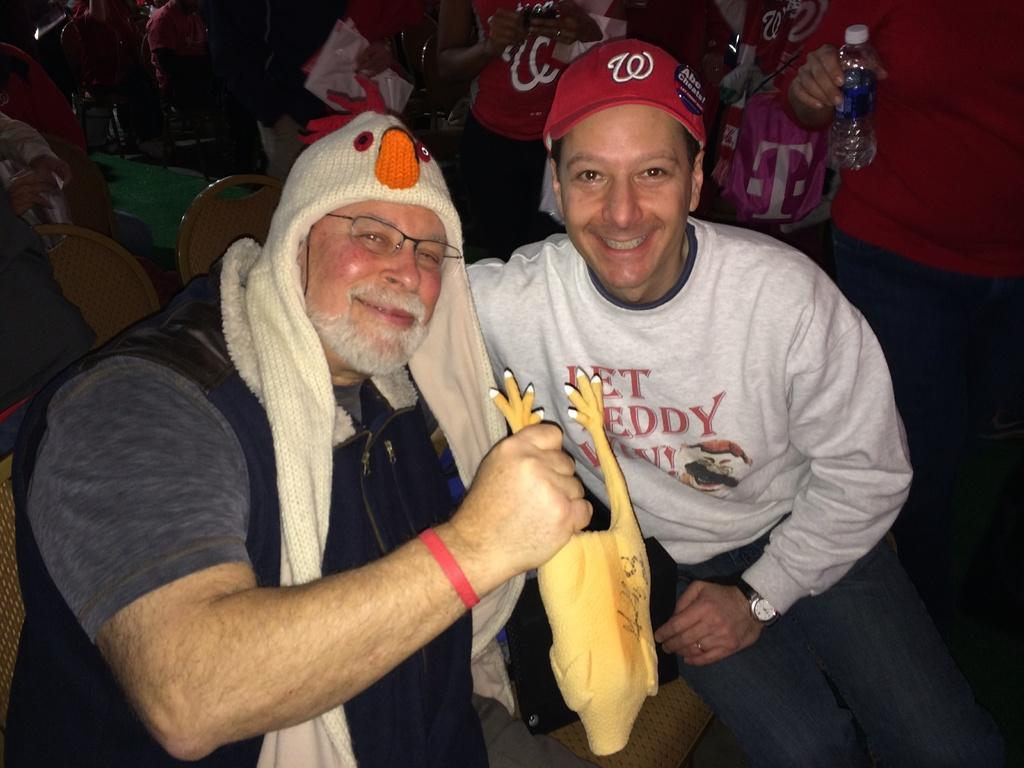<image>
Describe the image concisely. A crowd of people are sitting in seats and one of them has a pin on their hat that says Abe Cheats. 